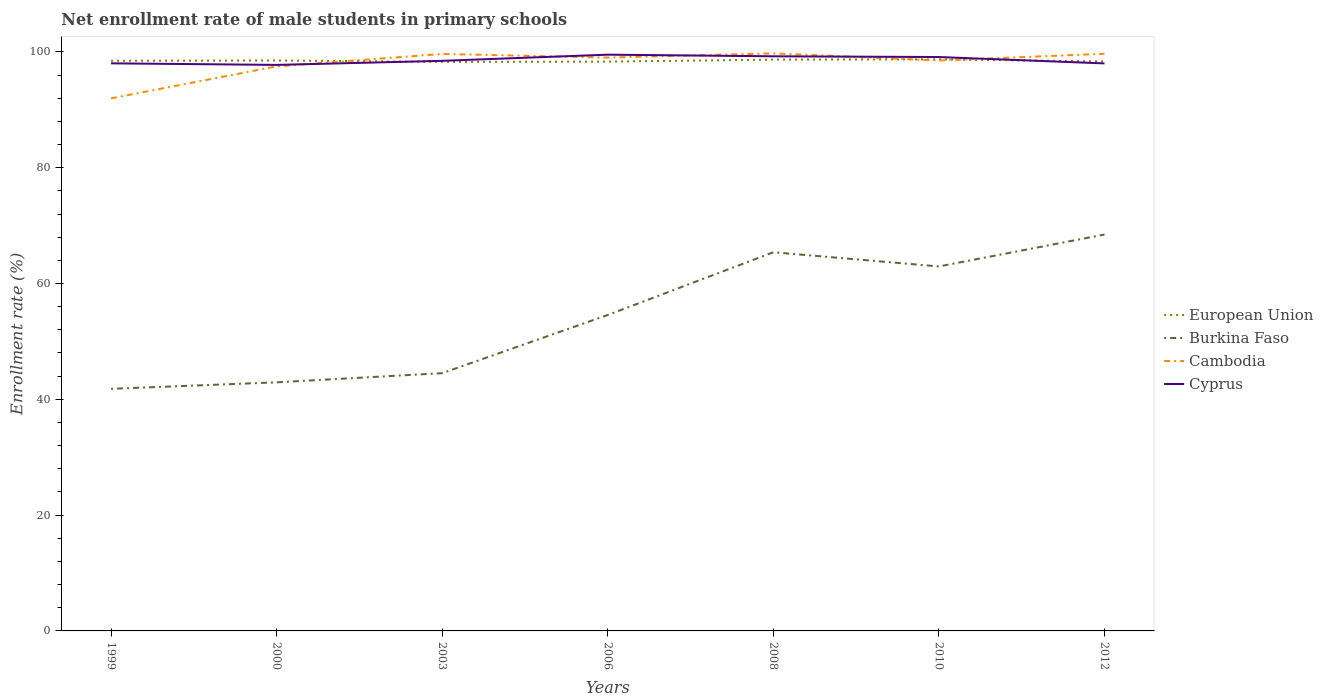Does the line corresponding to Cyprus intersect with the line corresponding to European Union?
Offer a terse response. Yes. Is the number of lines equal to the number of legend labels?
Provide a succinct answer. Yes. Across all years, what is the maximum net enrollment rate of male students in primary schools in Burkina Faso?
Provide a succinct answer. 41.81. What is the total net enrollment rate of male students in primary schools in Burkina Faso in the graph?
Your answer should be very brief. -20.01. What is the difference between the highest and the second highest net enrollment rate of male students in primary schools in Cyprus?
Make the answer very short. 1.77. How many lines are there?
Provide a short and direct response. 4. How many years are there in the graph?
Your response must be concise. 7. Where does the legend appear in the graph?
Your answer should be compact. Center right. How many legend labels are there?
Give a very brief answer. 4. What is the title of the graph?
Your response must be concise. Net enrollment rate of male students in primary schools. What is the label or title of the X-axis?
Provide a short and direct response. Years. What is the label or title of the Y-axis?
Give a very brief answer. Enrollment rate (%). What is the Enrollment rate (%) in European Union in 1999?
Give a very brief answer. 98.46. What is the Enrollment rate (%) of Burkina Faso in 1999?
Keep it short and to the point. 41.81. What is the Enrollment rate (%) in Cambodia in 1999?
Offer a very short reply. 91.98. What is the Enrollment rate (%) in Cyprus in 1999?
Offer a terse response. 98.03. What is the Enrollment rate (%) in European Union in 2000?
Ensure brevity in your answer.  98.53. What is the Enrollment rate (%) of Burkina Faso in 2000?
Keep it short and to the point. 42.94. What is the Enrollment rate (%) in Cambodia in 2000?
Give a very brief answer. 97.51. What is the Enrollment rate (%) of Cyprus in 2000?
Keep it short and to the point. 97.76. What is the Enrollment rate (%) of European Union in 2003?
Offer a very short reply. 98.28. What is the Enrollment rate (%) in Burkina Faso in 2003?
Your response must be concise. 44.52. What is the Enrollment rate (%) in Cambodia in 2003?
Your answer should be very brief. 99.65. What is the Enrollment rate (%) in Cyprus in 2003?
Keep it short and to the point. 98.46. What is the Enrollment rate (%) in European Union in 2006?
Your answer should be very brief. 98.32. What is the Enrollment rate (%) of Burkina Faso in 2006?
Make the answer very short. 54.57. What is the Enrollment rate (%) in Cambodia in 2006?
Provide a succinct answer. 99.02. What is the Enrollment rate (%) of Cyprus in 2006?
Offer a terse response. 99.52. What is the Enrollment rate (%) of European Union in 2008?
Ensure brevity in your answer.  98.67. What is the Enrollment rate (%) of Burkina Faso in 2008?
Ensure brevity in your answer.  65.4. What is the Enrollment rate (%) of Cambodia in 2008?
Provide a short and direct response. 99.75. What is the Enrollment rate (%) of Cyprus in 2008?
Ensure brevity in your answer.  99.24. What is the Enrollment rate (%) in European Union in 2010?
Make the answer very short. 98.72. What is the Enrollment rate (%) in Burkina Faso in 2010?
Provide a short and direct response. 62.95. What is the Enrollment rate (%) of Cambodia in 2010?
Your response must be concise. 98.52. What is the Enrollment rate (%) in Cyprus in 2010?
Ensure brevity in your answer.  99.12. What is the Enrollment rate (%) in European Union in 2012?
Make the answer very short. 98.35. What is the Enrollment rate (%) in Burkina Faso in 2012?
Ensure brevity in your answer.  68.46. What is the Enrollment rate (%) in Cambodia in 2012?
Your answer should be very brief. 99.68. What is the Enrollment rate (%) in Cyprus in 2012?
Your answer should be compact. 98.02. Across all years, what is the maximum Enrollment rate (%) of European Union?
Ensure brevity in your answer.  98.72. Across all years, what is the maximum Enrollment rate (%) in Burkina Faso?
Provide a short and direct response. 68.46. Across all years, what is the maximum Enrollment rate (%) in Cambodia?
Offer a very short reply. 99.75. Across all years, what is the maximum Enrollment rate (%) of Cyprus?
Offer a terse response. 99.52. Across all years, what is the minimum Enrollment rate (%) in European Union?
Provide a succinct answer. 98.28. Across all years, what is the minimum Enrollment rate (%) of Burkina Faso?
Keep it short and to the point. 41.81. Across all years, what is the minimum Enrollment rate (%) of Cambodia?
Your answer should be compact. 91.98. Across all years, what is the minimum Enrollment rate (%) of Cyprus?
Give a very brief answer. 97.76. What is the total Enrollment rate (%) of European Union in the graph?
Offer a very short reply. 689.32. What is the total Enrollment rate (%) in Burkina Faso in the graph?
Your response must be concise. 380.64. What is the total Enrollment rate (%) of Cambodia in the graph?
Your answer should be compact. 686.11. What is the total Enrollment rate (%) of Cyprus in the graph?
Your answer should be very brief. 690.14. What is the difference between the Enrollment rate (%) of European Union in 1999 and that in 2000?
Your answer should be very brief. -0.06. What is the difference between the Enrollment rate (%) of Burkina Faso in 1999 and that in 2000?
Give a very brief answer. -1.12. What is the difference between the Enrollment rate (%) of Cambodia in 1999 and that in 2000?
Offer a terse response. -5.53. What is the difference between the Enrollment rate (%) of Cyprus in 1999 and that in 2000?
Offer a very short reply. 0.27. What is the difference between the Enrollment rate (%) of European Union in 1999 and that in 2003?
Keep it short and to the point. 0.19. What is the difference between the Enrollment rate (%) in Burkina Faso in 1999 and that in 2003?
Ensure brevity in your answer.  -2.7. What is the difference between the Enrollment rate (%) of Cambodia in 1999 and that in 2003?
Provide a succinct answer. -7.67. What is the difference between the Enrollment rate (%) of Cyprus in 1999 and that in 2003?
Offer a terse response. -0.43. What is the difference between the Enrollment rate (%) of European Union in 1999 and that in 2006?
Offer a very short reply. 0.14. What is the difference between the Enrollment rate (%) of Burkina Faso in 1999 and that in 2006?
Offer a terse response. -12.75. What is the difference between the Enrollment rate (%) in Cambodia in 1999 and that in 2006?
Give a very brief answer. -7.04. What is the difference between the Enrollment rate (%) in Cyprus in 1999 and that in 2006?
Give a very brief answer. -1.49. What is the difference between the Enrollment rate (%) of European Union in 1999 and that in 2008?
Your answer should be compact. -0.21. What is the difference between the Enrollment rate (%) of Burkina Faso in 1999 and that in 2008?
Give a very brief answer. -23.59. What is the difference between the Enrollment rate (%) in Cambodia in 1999 and that in 2008?
Provide a succinct answer. -7.77. What is the difference between the Enrollment rate (%) in Cyprus in 1999 and that in 2008?
Keep it short and to the point. -1.21. What is the difference between the Enrollment rate (%) in European Union in 1999 and that in 2010?
Provide a short and direct response. -0.26. What is the difference between the Enrollment rate (%) of Burkina Faso in 1999 and that in 2010?
Offer a very short reply. -21.14. What is the difference between the Enrollment rate (%) of Cambodia in 1999 and that in 2010?
Provide a succinct answer. -6.54. What is the difference between the Enrollment rate (%) in Cyprus in 1999 and that in 2010?
Make the answer very short. -1.09. What is the difference between the Enrollment rate (%) in European Union in 1999 and that in 2012?
Offer a terse response. 0.11. What is the difference between the Enrollment rate (%) of Burkina Faso in 1999 and that in 2012?
Your answer should be very brief. -26.64. What is the difference between the Enrollment rate (%) of Cambodia in 1999 and that in 2012?
Your answer should be compact. -7.7. What is the difference between the Enrollment rate (%) of Cyprus in 1999 and that in 2012?
Offer a terse response. 0.01. What is the difference between the Enrollment rate (%) of European Union in 2000 and that in 2003?
Give a very brief answer. 0.25. What is the difference between the Enrollment rate (%) of Burkina Faso in 2000 and that in 2003?
Ensure brevity in your answer.  -1.58. What is the difference between the Enrollment rate (%) of Cambodia in 2000 and that in 2003?
Offer a terse response. -2.14. What is the difference between the Enrollment rate (%) of Cyprus in 2000 and that in 2003?
Make the answer very short. -0.71. What is the difference between the Enrollment rate (%) in European Union in 2000 and that in 2006?
Provide a succinct answer. 0.2. What is the difference between the Enrollment rate (%) in Burkina Faso in 2000 and that in 2006?
Give a very brief answer. -11.63. What is the difference between the Enrollment rate (%) of Cambodia in 2000 and that in 2006?
Provide a short and direct response. -1.51. What is the difference between the Enrollment rate (%) of Cyprus in 2000 and that in 2006?
Offer a terse response. -1.77. What is the difference between the Enrollment rate (%) of European Union in 2000 and that in 2008?
Ensure brevity in your answer.  -0.14. What is the difference between the Enrollment rate (%) of Burkina Faso in 2000 and that in 2008?
Offer a very short reply. -22.46. What is the difference between the Enrollment rate (%) of Cambodia in 2000 and that in 2008?
Your answer should be compact. -2.24. What is the difference between the Enrollment rate (%) in Cyprus in 2000 and that in 2008?
Provide a short and direct response. -1.49. What is the difference between the Enrollment rate (%) of European Union in 2000 and that in 2010?
Your answer should be compact. -0.19. What is the difference between the Enrollment rate (%) of Burkina Faso in 2000 and that in 2010?
Provide a short and direct response. -20.01. What is the difference between the Enrollment rate (%) of Cambodia in 2000 and that in 2010?
Make the answer very short. -1.01. What is the difference between the Enrollment rate (%) in Cyprus in 2000 and that in 2010?
Give a very brief answer. -1.36. What is the difference between the Enrollment rate (%) of European Union in 2000 and that in 2012?
Your answer should be compact. 0.17. What is the difference between the Enrollment rate (%) of Burkina Faso in 2000 and that in 2012?
Make the answer very short. -25.52. What is the difference between the Enrollment rate (%) of Cambodia in 2000 and that in 2012?
Offer a very short reply. -2.17. What is the difference between the Enrollment rate (%) in Cyprus in 2000 and that in 2012?
Ensure brevity in your answer.  -0.26. What is the difference between the Enrollment rate (%) in European Union in 2003 and that in 2006?
Your answer should be very brief. -0.05. What is the difference between the Enrollment rate (%) in Burkina Faso in 2003 and that in 2006?
Provide a short and direct response. -10.05. What is the difference between the Enrollment rate (%) of Cambodia in 2003 and that in 2006?
Give a very brief answer. 0.63. What is the difference between the Enrollment rate (%) of Cyprus in 2003 and that in 2006?
Provide a short and direct response. -1.06. What is the difference between the Enrollment rate (%) of European Union in 2003 and that in 2008?
Provide a succinct answer. -0.39. What is the difference between the Enrollment rate (%) in Burkina Faso in 2003 and that in 2008?
Offer a very short reply. -20.88. What is the difference between the Enrollment rate (%) in Cambodia in 2003 and that in 2008?
Provide a succinct answer. -0.1. What is the difference between the Enrollment rate (%) in Cyprus in 2003 and that in 2008?
Your response must be concise. -0.78. What is the difference between the Enrollment rate (%) of European Union in 2003 and that in 2010?
Keep it short and to the point. -0.44. What is the difference between the Enrollment rate (%) in Burkina Faso in 2003 and that in 2010?
Your response must be concise. -18.43. What is the difference between the Enrollment rate (%) in Cambodia in 2003 and that in 2010?
Ensure brevity in your answer.  1.13. What is the difference between the Enrollment rate (%) in Cyprus in 2003 and that in 2010?
Offer a very short reply. -0.65. What is the difference between the Enrollment rate (%) in European Union in 2003 and that in 2012?
Your answer should be compact. -0.08. What is the difference between the Enrollment rate (%) in Burkina Faso in 2003 and that in 2012?
Make the answer very short. -23.94. What is the difference between the Enrollment rate (%) of Cambodia in 2003 and that in 2012?
Offer a terse response. -0.03. What is the difference between the Enrollment rate (%) of Cyprus in 2003 and that in 2012?
Offer a terse response. 0.45. What is the difference between the Enrollment rate (%) of European Union in 2006 and that in 2008?
Offer a terse response. -0.35. What is the difference between the Enrollment rate (%) in Burkina Faso in 2006 and that in 2008?
Offer a terse response. -10.83. What is the difference between the Enrollment rate (%) in Cambodia in 2006 and that in 2008?
Offer a terse response. -0.73. What is the difference between the Enrollment rate (%) in Cyprus in 2006 and that in 2008?
Your answer should be very brief. 0.28. What is the difference between the Enrollment rate (%) of European Union in 2006 and that in 2010?
Your answer should be very brief. -0.39. What is the difference between the Enrollment rate (%) in Burkina Faso in 2006 and that in 2010?
Offer a very short reply. -8.38. What is the difference between the Enrollment rate (%) of Cambodia in 2006 and that in 2010?
Keep it short and to the point. 0.51. What is the difference between the Enrollment rate (%) of Cyprus in 2006 and that in 2010?
Your response must be concise. 0.41. What is the difference between the Enrollment rate (%) in European Union in 2006 and that in 2012?
Offer a terse response. -0.03. What is the difference between the Enrollment rate (%) in Burkina Faso in 2006 and that in 2012?
Give a very brief answer. -13.89. What is the difference between the Enrollment rate (%) in Cambodia in 2006 and that in 2012?
Make the answer very short. -0.66. What is the difference between the Enrollment rate (%) of Cyprus in 2006 and that in 2012?
Offer a terse response. 1.51. What is the difference between the Enrollment rate (%) of European Union in 2008 and that in 2010?
Your answer should be very brief. -0.05. What is the difference between the Enrollment rate (%) of Burkina Faso in 2008 and that in 2010?
Your answer should be compact. 2.45. What is the difference between the Enrollment rate (%) of Cambodia in 2008 and that in 2010?
Provide a short and direct response. 1.24. What is the difference between the Enrollment rate (%) of Cyprus in 2008 and that in 2010?
Your answer should be very brief. 0.13. What is the difference between the Enrollment rate (%) of European Union in 2008 and that in 2012?
Ensure brevity in your answer.  0.32. What is the difference between the Enrollment rate (%) in Burkina Faso in 2008 and that in 2012?
Provide a short and direct response. -3.06. What is the difference between the Enrollment rate (%) of Cambodia in 2008 and that in 2012?
Make the answer very short. 0.07. What is the difference between the Enrollment rate (%) in Cyprus in 2008 and that in 2012?
Your response must be concise. 1.23. What is the difference between the Enrollment rate (%) of European Union in 2010 and that in 2012?
Give a very brief answer. 0.37. What is the difference between the Enrollment rate (%) in Burkina Faso in 2010 and that in 2012?
Keep it short and to the point. -5.51. What is the difference between the Enrollment rate (%) in Cambodia in 2010 and that in 2012?
Your answer should be very brief. -1.16. What is the difference between the Enrollment rate (%) of Cyprus in 2010 and that in 2012?
Make the answer very short. 1.1. What is the difference between the Enrollment rate (%) of European Union in 1999 and the Enrollment rate (%) of Burkina Faso in 2000?
Your answer should be compact. 55.53. What is the difference between the Enrollment rate (%) of European Union in 1999 and the Enrollment rate (%) of Cambodia in 2000?
Your answer should be very brief. 0.95. What is the difference between the Enrollment rate (%) of European Union in 1999 and the Enrollment rate (%) of Cyprus in 2000?
Make the answer very short. 0.71. What is the difference between the Enrollment rate (%) in Burkina Faso in 1999 and the Enrollment rate (%) in Cambodia in 2000?
Give a very brief answer. -55.7. What is the difference between the Enrollment rate (%) of Burkina Faso in 1999 and the Enrollment rate (%) of Cyprus in 2000?
Offer a terse response. -55.94. What is the difference between the Enrollment rate (%) in Cambodia in 1999 and the Enrollment rate (%) in Cyprus in 2000?
Provide a succinct answer. -5.77. What is the difference between the Enrollment rate (%) in European Union in 1999 and the Enrollment rate (%) in Burkina Faso in 2003?
Provide a short and direct response. 53.94. What is the difference between the Enrollment rate (%) of European Union in 1999 and the Enrollment rate (%) of Cambodia in 2003?
Your answer should be compact. -1.19. What is the difference between the Enrollment rate (%) of European Union in 1999 and the Enrollment rate (%) of Cyprus in 2003?
Ensure brevity in your answer.  -0. What is the difference between the Enrollment rate (%) in Burkina Faso in 1999 and the Enrollment rate (%) in Cambodia in 2003?
Ensure brevity in your answer.  -57.84. What is the difference between the Enrollment rate (%) of Burkina Faso in 1999 and the Enrollment rate (%) of Cyprus in 2003?
Ensure brevity in your answer.  -56.65. What is the difference between the Enrollment rate (%) of Cambodia in 1999 and the Enrollment rate (%) of Cyprus in 2003?
Offer a terse response. -6.48. What is the difference between the Enrollment rate (%) in European Union in 1999 and the Enrollment rate (%) in Burkina Faso in 2006?
Your answer should be very brief. 43.89. What is the difference between the Enrollment rate (%) of European Union in 1999 and the Enrollment rate (%) of Cambodia in 2006?
Give a very brief answer. -0.56. What is the difference between the Enrollment rate (%) in European Union in 1999 and the Enrollment rate (%) in Cyprus in 2006?
Your answer should be compact. -1.06. What is the difference between the Enrollment rate (%) of Burkina Faso in 1999 and the Enrollment rate (%) of Cambodia in 2006?
Ensure brevity in your answer.  -57.21. What is the difference between the Enrollment rate (%) in Burkina Faso in 1999 and the Enrollment rate (%) in Cyprus in 2006?
Provide a succinct answer. -57.71. What is the difference between the Enrollment rate (%) of Cambodia in 1999 and the Enrollment rate (%) of Cyprus in 2006?
Ensure brevity in your answer.  -7.54. What is the difference between the Enrollment rate (%) in European Union in 1999 and the Enrollment rate (%) in Burkina Faso in 2008?
Your answer should be compact. 33.06. What is the difference between the Enrollment rate (%) in European Union in 1999 and the Enrollment rate (%) in Cambodia in 2008?
Provide a succinct answer. -1.29. What is the difference between the Enrollment rate (%) of European Union in 1999 and the Enrollment rate (%) of Cyprus in 2008?
Offer a terse response. -0.78. What is the difference between the Enrollment rate (%) in Burkina Faso in 1999 and the Enrollment rate (%) in Cambodia in 2008?
Ensure brevity in your answer.  -57.94. What is the difference between the Enrollment rate (%) of Burkina Faso in 1999 and the Enrollment rate (%) of Cyprus in 2008?
Provide a short and direct response. -57.43. What is the difference between the Enrollment rate (%) of Cambodia in 1999 and the Enrollment rate (%) of Cyprus in 2008?
Provide a succinct answer. -7.26. What is the difference between the Enrollment rate (%) in European Union in 1999 and the Enrollment rate (%) in Burkina Faso in 2010?
Offer a very short reply. 35.51. What is the difference between the Enrollment rate (%) of European Union in 1999 and the Enrollment rate (%) of Cambodia in 2010?
Make the answer very short. -0.06. What is the difference between the Enrollment rate (%) of European Union in 1999 and the Enrollment rate (%) of Cyprus in 2010?
Make the answer very short. -0.65. What is the difference between the Enrollment rate (%) of Burkina Faso in 1999 and the Enrollment rate (%) of Cambodia in 2010?
Provide a short and direct response. -56.7. What is the difference between the Enrollment rate (%) of Burkina Faso in 1999 and the Enrollment rate (%) of Cyprus in 2010?
Give a very brief answer. -57.3. What is the difference between the Enrollment rate (%) in Cambodia in 1999 and the Enrollment rate (%) in Cyprus in 2010?
Offer a terse response. -7.13. What is the difference between the Enrollment rate (%) of European Union in 1999 and the Enrollment rate (%) of Burkina Faso in 2012?
Your answer should be compact. 30.01. What is the difference between the Enrollment rate (%) of European Union in 1999 and the Enrollment rate (%) of Cambodia in 2012?
Provide a short and direct response. -1.22. What is the difference between the Enrollment rate (%) in European Union in 1999 and the Enrollment rate (%) in Cyprus in 2012?
Provide a short and direct response. 0.44. What is the difference between the Enrollment rate (%) in Burkina Faso in 1999 and the Enrollment rate (%) in Cambodia in 2012?
Give a very brief answer. -57.87. What is the difference between the Enrollment rate (%) in Burkina Faso in 1999 and the Enrollment rate (%) in Cyprus in 2012?
Provide a succinct answer. -56.2. What is the difference between the Enrollment rate (%) of Cambodia in 1999 and the Enrollment rate (%) of Cyprus in 2012?
Make the answer very short. -6.04. What is the difference between the Enrollment rate (%) in European Union in 2000 and the Enrollment rate (%) in Burkina Faso in 2003?
Your answer should be very brief. 54.01. What is the difference between the Enrollment rate (%) in European Union in 2000 and the Enrollment rate (%) in Cambodia in 2003?
Your answer should be very brief. -1.12. What is the difference between the Enrollment rate (%) in European Union in 2000 and the Enrollment rate (%) in Cyprus in 2003?
Provide a succinct answer. 0.06. What is the difference between the Enrollment rate (%) of Burkina Faso in 2000 and the Enrollment rate (%) of Cambodia in 2003?
Your answer should be compact. -56.71. What is the difference between the Enrollment rate (%) in Burkina Faso in 2000 and the Enrollment rate (%) in Cyprus in 2003?
Provide a short and direct response. -55.53. What is the difference between the Enrollment rate (%) in Cambodia in 2000 and the Enrollment rate (%) in Cyprus in 2003?
Your answer should be very brief. -0.95. What is the difference between the Enrollment rate (%) of European Union in 2000 and the Enrollment rate (%) of Burkina Faso in 2006?
Provide a short and direct response. 43.96. What is the difference between the Enrollment rate (%) in European Union in 2000 and the Enrollment rate (%) in Cambodia in 2006?
Your response must be concise. -0.5. What is the difference between the Enrollment rate (%) of European Union in 2000 and the Enrollment rate (%) of Cyprus in 2006?
Offer a very short reply. -1. What is the difference between the Enrollment rate (%) in Burkina Faso in 2000 and the Enrollment rate (%) in Cambodia in 2006?
Your answer should be very brief. -56.09. What is the difference between the Enrollment rate (%) in Burkina Faso in 2000 and the Enrollment rate (%) in Cyprus in 2006?
Make the answer very short. -56.59. What is the difference between the Enrollment rate (%) of Cambodia in 2000 and the Enrollment rate (%) of Cyprus in 2006?
Your answer should be compact. -2.01. What is the difference between the Enrollment rate (%) of European Union in 2000 and the Enrollment rate (%) of Burkina Faso in 2008?
Provide a succinct answer. 33.12. What is the difference between the Enrollment rate (%) of European Union in 2000 and the Enrollment rate (%) of Cambodia in 2008?
Keep it short and to the point. -1.23. What is the difference between the Enrollment rate (%) in European Union in 2000 and the Enrollment rate (%) in Cyprus in 2008?
Provide a short and direct response. -0.72. What is the difference between the Enrollment rate (%) of Burkina Faso in 2000 and the Enrollment rate (%) of Cambodia in 2008?
Keep it short and to the point. -56.82. What is the difference between the Enrollment rate (%) of Burkina Faso in 2000 and the Enrollment rate (%) of Cyprus in 2008?
Make the answer very short. -56.31. What is the difference between the Enrollment rate (%) of Cambodia in 2000 and the Enrollment rate (%) of Cyprus in 2008?
Offer a very short reply. -1.73. What is the difference between the Enrollment rate (%) in European Union in 2000 and the Enrollment rate (%) in Burkina Faso in 2010?
Keep it short and to the point. 35.58. What is the difference between the Enrollment rate (%) in European Union in 2000 and the Enrollment rate (%) in Cambodia in 2010?
Offer a terse response. 0.01. What is the difference between the Enrollment rate (%) of European Union in 2000 and the Enrollment rate (%) of Cyprus in 2010?
Keep it short and to the point. -0.59. What is the difference between the Enrollment rate (%) in Burkina Faso in 2000 and the Enrollment rate (%) in Cambodia in 2010?
Keep it short and to the point. -55.58. What is the difference between the Enrollment rate (%) of Burkina Faso in 2000 and the Enrollment rate (%) of Cyprus in 2010?
Make the answer very short. -56.18. What is the difference between the Enrollment rate (%) in Cambodia in 2000 and the Enrollment rate (%) in Cyprus in 2010?
Your answer should be very brief. -1.61. What is the difference between the Enrollment rate (%) in European Union in 2000 and the Enrollment rate (%) in Burkina Faso in 2012?
Provide a succinct answer. 30.07. What is the difference between the Enrollment rate (%) of European Union in 2000 and the Enrollment rate (%) of Cambodia in 2012?
Provide a succinct answer. -1.16. What is the difference between the Enrollment rate (%) in European Union in 2000 and the Enrollment rate (%) in Cyprus in 2012?
Your answer should be very brief. 0.51. What is the difference between the Enrollment rate (%) of Burkina Faso in 2000 and the Enrollment rate (%) of Cambodia in 2012?
Give a very brief answer. -56.74. What is the difference between the Enrollment rate (%) of Burkina Faso in 2000 and the Enrollment rate (%) of Cyprus in 2012?
Provide a short and direct response. -55.08. What is the difference between the Enrollment rate (%) of Cambodia in 2000 and the Enrollment rate (%) of Cyprus in 2012?
Make the answer very short. -0.51. What is the difference between the Enrollment rate (%) of European Union in 2003 and the Enrollment rate (%) of Burkina Faso in 2006?
Your response must be concise. 43.71. What is the difference between the Enrollment rate (%) in European Union in 2003 and the Enrollment rate (%) in Cambodia in 2006?
Keep it short and to the point. -0.75. What is the difference between the Enrollment rate (%) of European Union in 2003 and the Enrollment rate (%) of Cyprus in 2006?
Provide a succinct answer. -1.25. What is the difference between the Enrollment rate (%) of Burkina Faso in 2003 and the Enrollment rate (%) of Cambodia in 2006?
Your answer should be compact. -54.51. What is the difference between the Enrollment rate (%) of Burkina Faso in 2003 and the Enrollment rate (%) of Cyprus in 2006?
Your answer should be compact. -55.01. What is the difference between the Enrollment rate (%) of Cambodia in 2003 and the Enrollment rate (%) of Cyprus in 2006?
Keep it short and to the point. 0.13. What is the difference between the Enrollment rate (%) of European Union in 2003 and the Enrollment rate (%) of Burkina Faso in 2008?
Provide a short and direct response. 32.88. What is the difference between the Enrollment rate (%) of European Union in 2003 and the Enrollment rate (%) of Cambodia in 2008?
Offer a very short reply. -1.48. What is the difference between the Enrollment rate (%) in European Union in 2003 and the Enrollment rate (%) in Cyprus in 2008?
Offer a very short reply. -0.97. What is the difference between the Enrollment rate (%) of Burkina Faso in 2003 and the Enrollment rate (%) of Cambodia in 2008?
Your answer should be very brief. -55.24. What is the difference between the Enrollment rate (%) of Burkina Faso in 2003 and the Enrollment rate (%) of Cyprus in 2008?
Make the answer very short. -54.73. What is the difference between the Enrollment rate (%) of Cambodia in 2003 and the Enrollment rate (%) of Cyprus in 2008?
Give a very brief answer. 0.41. What is the difference between the Enrollment rate (%) in European Union in 2003 and the Enrollment rate (%) in Burkina Faso in 2010?
Keep it short and to the point. 35.33. What is the difference between the Enrollment rate (%) in European Union in 2003 and the Enrollment rate (%) in Cambodia in 2010?
Keep it short and to the point. -0.24. What is the difference between the Enrollment rate (%) in European Union in 2003 and the Enrollment rate (%) in Cyprus in 2010?
Give a very brief answer. -0.84. What is the difference between the Enrollment rate (%) in Burkina Faso in 2003 and the Enrollment rate (%) in Cambodia in 2010?
Ensure brevity in your answer.  -54. What is the difference between the Enrollment rate (%) in Burkina Faso in 2003 and the Enrollment rate (%) in Cyprus in 2010?
Provide a short and direct response. -54.6. What is the difference between the Enrollment rate (%) in Cambodia in 2003 and the Enrollment rate (%) in Cyprus in 2010?
Make the answer very short. 0.53. What is the difference between the Enrollment rate (%) of European Union in 2003 and the Enrollment rate (%) of Burkina Faso in 2012?
Ensure brevity in your answer.  29.82. What is the difference between the Enrollment rate (%) of European Union in 2003 and the Enrollment rate (%) of Cambodia in 2012?
Make the answer very short. -1.4. What is the difference between the Enrollment rate (%) of European Union in 2003 and the Enrollment rate (%) of Cyprus in 2012?
Provide a short and direct response. 0.26. What is the difference between the Enrollment rate (%) in Burkina Faso in 2003 and the Enrollment rate (%) in Cambodia in 2012?
Provide a succinct answer. -55.16. What is the difference between the Enrollment rate (%) of Burkina Faso in 2003 and the Enrollment rate (%) of Cyprus in 2012?
Your answer should be very brief. -53.5. What is the difference between the Enrollment rate (%) of Cambodia in 2003 and the Enrollment rate (%) of Cyprus in 2012?
Your answer should be compact. 1.63. What is the difference between the Enrollment rate (%) in European Union in 2006 and the Enrollment rate (%) in Burkina Faso in 2008?
Offer a terse response. 32.92. What is the difference between the Enrollment rate (%) in European Union in 2006 and the Enrollment rate (%) in Cambodia in 2008?
Your answer should be compact. -1.43. What is the difference between the Enrollment rate (%) in European Union in 2006 and the Enrollment rate (%) in Cyprus in 2008?
Your answer should be compact. -0.92. What is the difference between the Enrollment rate (%) in Burkina Faso in 2006 and the Enrollment rate (%) in Cambodia in 2008?
Give a very brief answer. -45.18. What is the difference between the Enrollment rate (%) of Burkina Faso in 2006 and the Enrollment rate (%) of Cyprus in 2008?
Give a very brief answer. -44.67. What is the difference between the Enrollment rate (%) in Cambodia in 2006 and the Enrollment rate (%) in Cyprus in 2008?
Keep it short and to the point. -0.22. What is the difference between the Enrollment rate (%) in European Union in 2006 and the Enrollment rate (%) in Burkina Faso in 2010?
Make the answer very short. 35.37. What is the difference between the Enrollment rate (%) in European Union in 2006 and the Enrollment rate (%) in Cambodia in 2010?
Your response must be concise. -0.19. What is the difference between the Enrollment rate (%) in European Union in 2006 and the Enrollment rate (%) in Cyprus in 2010?
Keep it short and to the point. -0.79. What is the difference between the Enrollment rate (%) of Burkina Faso in 2006 and the Enrollment rate (%) of Cambodia in 2010?
Your answer should be compact. -43.95. What is the difference between the Enrollment rate (%) in Burkina Faso in 2006 and the Enrollment rate (%) in Cyprus in 2010?
Offer a terse response. -44.55. What is the difference between the Enrollment rate (%) of Cambodia in 2006 and the Enrollment rate (%) of Cyprus in 2010?
Keep it short and to the point. -0.09. What is the difference between the Enrollment rate (%) of European Union in 2006 and the Enrollment rate (%) of Burkina Faso in 2012?
Make the answer very short. 29.87. What is the difference between the Enrollment rate (%) of European Union in 2006 and the Enrollment rate (%) of Cambodia in 2012?
Offer a terse response. -1.36. What is the difference between the Enrollment rate (%) in European Union in 2006 and the Enrollment rate (%) in Cyprus in 2012?
Your answer should be compact. 0.31. What is the difference between the Enrollment rate (%) in Burkina Faso in 2006 and the Enrollment rate (%) in Cambodia in 2012?
Provide a succinct answer. -45.11. What is the difference between the Enrollment rate (%) in Burkina Faso in 2006 and the Enrollment rate (%) in Cyprus in 2012?
Ensure brevity in your answer.  -43.45. What is the difference between the Enrollment rate (%) in Cambodia in 2006 and the Enrollment rate (%) in Cyprus in 2012?
Keep it short and to the point. 1.01. What is the difference between the Enrollment rate (%) of European Union in 2008 and the Enrollment rate (%) of Burkina Faso in 2010?
Keep it short and to the point. 35.72. What is the difference between the Enrollment rate (%) of European Union in 2008 and the Enrollment rate (%) of Cambodia in 2010?
Your response must be concise. 0.15. What is the difference between the Enrollment rate (%) of European Union in 2008 and the Enrollment rate (%) of Cyprus in 2010?
Your answer should be compact. -0.45. What is the difference between the Enrollment rate (%) in Burkina Faso in 2008 and the Enrollment rate (%) in Cambodia in 2010?
Give a very brief answer. -33.12. What is the difference between the Enrollment rate (%) of Burkina Faso in 2008 and the Enrollment rate (%) of Cyprus in 2010?
Give a very brief answer. -33.72. What is the difference between the Enrollment rate (%) in Cambodia in 2008 and the Enrollment rate (%) in Cyprus in 2010?
Your response must be concise. 0.64. What is the difference between the Enrollment rate (%) of European Union in 2008 and the Enrollment rate (%) of Burkina Faso in 2012?
Provide a short and direct response. 30.21. What is the difference between the Enrollment rate (%) in European Union in 2008 and the Enrollment rate (%) in Cambodia in 2012?
Offer a very short reply. -1.01. What is the difference between the Enrollment rate (%) in European Union in 2008 and the Enrollment rate (%) in Cyprus in 2012?
Keep it short and to the point. 0.65. What is the difference between the Enrollment rate (%) in Burkina Faso in 2008 and the Enrollment rate (%) in Cambodia in 2012?
Offer a terse response. -34.28. What is the difference between the Enrollment rate (%) in Burkina Faso in 2008 and the Enrollment rate (%) in Cyprus in 2012?
Provide a succinct answer. -32.62. What is the difference between the Enrollment rate (%) in Cambodia in 2008 and the Enrollment rate (%) in Cyprus in 2012?
Give a very brief answer. 1.74. What is the difference between the Enrollment rate (%) of European Union in 2010 and the Enrollment rate (%) of Burkina Faso in 2012?
Offer a terse response. 30.26. What is the difference between the Enrollment rate (%) in European Union in 2010 and the Enrollment rate (%) in Cambodia in 2012?
Give a very brief answer. -0.96. What is the difference between the Enrollment rate (%) in European Union in 2010 and the Enrollment rate (%) in Cyprus in 2012?
Offer a terse response. 0.7. What is the difference between the Enrollment rate (%) of Burkina Faso in 2010 and the Enrollment rate (%) of Cambodia in 2012?
Your response must be concise. -36.73. What is the difference between the Enrollment rate (%) in Burkina Faso in 2010 and the Enrollment rate (%) in Cyprus in 2012?
Give a very brief answer. -35.07. What is the difference between the Enrollment rate (%) in Cambodia in 2010 and the Enrollment rate (%) in Cyprus in 2012?
Keep it short and to the point. 0.5. What is the average Enrollment rate (%) in European Union per year?
Your answer should be compact. 98.47. What is the average Enrollment rate (%) of Burkina Faso per year?
Make the answer very short. 54.38. What is the average Enrollment rate (%) of Cambodia per year?
Provide a succinct answer. 98.02. What is the average Enrollment rate (%) of Cyprus per year?
Provide a succinct answer. 98.59. In the year 1999, what is the difference between the Enrollment rate (%) of European Union and Enrollment rate (%) of Burkina Faso?
Offer a very short reply. 56.65. In the year 1999, what is the difference between the Enrollment rate (%) of European Union and Enrollment rate (%) of Cambodia?
Offer a very short reply. 6.48. In the year 1999, what is the difference between the Enrollment rate (%) in European Union and Enrollment rate (%) in Cyprus?
Your response must be concise. 0.43. In the year 1999, what is the difference between the Enrollment rate (%) of Burkina Faso and Enrollment rate (%) of Cambodia?
Keep it short and to the point. -50.17. In the year 1999, what is the difference between the Enrollment rate (%) of Burkina Faso and Enrollment rate (%) of Cyprus?
Make the answer very short. -56.22. In the year 1999, what is the difference between the Enrollment rate (%) of Cambodia and Enrollment rate (%) of Cyprus?
Offer a very short reply. -6.05. In the year 2000, what is the difference between the Enrollment rate (%) of European Union and Enrollment rate (%) of Burkina Faso?
Ensure brevity in your answer.  55.59. In the year 2000, what is the difference between the Enrollment rate (%) in European Union and Enrollment rate (%) in Cambodia?
Give a very brief answer. 1.02. In the year 2000, what is the difference between the Enrollment rate (%) of European Union and Enrollment rate (%) of Cyprus?
Give a very brief answer. 0.77. In the year 2000, what is the difference between the Enrollment rate (%) in Burkina Faso and Enrollment rate (%) in Cambodia?
Provide a short and direct response. -54.57. In the year 2000, what is the difference between the Enrollment rate (%) in Burkina Faso and Enrollment rate (%) in Cyprus?
Provide a succinct answer. -54.82. In the year 2000, what is the difference between the Enrollment rate (%) of Cambodia and Enrollment rate (%) of Cyprus?
Offer a terse response. -0.25. In the year 2003, what is the difference between the Enrollment rate (%) in European Union and Enrollment rate (%) in Burkina Faso?
Provide a succinct answer. 53.76. In the year 2003, what is the difference between the Enrollment rate (%) of European Union and Enrollment rate (%) of Cambodia?
Your answer should be compact. -1.37. In the year 2003, what is the difference between the Enrollment rate (%) in European Union and Enrollment rate (%) in Cyprus?
Make the answer very short. -0.19. In the year 2003, what is the difference between the Enrollment rate (%) of Burkina Faso and Enrollment rate (%) of Cambodia?
Ensure brevity in your answer.  -55.13. In the year 2003, what is the difference between the Enrollment rate (%) in Burkina Faso and Enrollment rate (%) in Cyprus?
Give a very brief answer. -53.95. In the year 2003, what is the difference between the Enrollment rate (%) of Cambodia and Enrollment rate (%) of Cyprus?
Your answer should be compact. 1.19. In the year 2006, what is the difference between the Enrollment rate (%) of European Union and Enrollment rate (%) of Burkina Faso?
Give a very brief answer. 43.76. In the year 2006, what is the difference between the Enrollment rate (%) of European Union and Enrollment rate (%) of Cambodia?
Your answer should be compact. -0.7. In the year 2006, what is the difference between the Enrollment rate (%) of European Union and Enrollment rate (%) of Cyprus?
Keep it short and to the point. -1.2. In the year 2006, what is the difference between the Enrollment rate (%) in Burkina Faso and Enrollment rate (%) in Cambodia?
Offer a very short reply. -44.45. In the year 2006, what is the difference between the Enrollment rate (%) of Burkina Faso and Enrollment rate (%) of Cyprus?
Give a very brief answer. -44.96. In the year 2006, what is the difference between the Enrollment rate (%) of Cambodia and Enrollment rate (%) of Cyprus?
Ensure brevity in your answer.  -0.5. In the year 2008, what is the difference between the Enrollment rate (%) of European Union and Enrollment rate (%) of Burkina Faso?
Provide a succinct answer. 33.27. In the year 2008, what is the difference between the Enrollment rate (%) in European Union and Enrollment rate (%) in Cambodia?
Provide a succinct answer. -1.08. In the year 2008, what is the difference between the Enrollment rate (%) in European Union and Enrollment rate (%) in Cyprus?
Your answer should be very brief. -0.57. In the year 2008, what is the difference between the Enrollment rate (%) in Burkina Faso and Enrollment rate (%) in Cambodia?
Your answer should be very brief. -34.35. In the year 2008, what is the difference between the Enrollment rate (%) of Burkina Faso and Enrollment rate (%) of Cyprus?
Your response must be concise. -33.84. In the year 2008, what is the difference between the Enrollment rate (%) of Cambodia and Enrollment rate (%) of Cyprus?
Make the answer very short. 0.51. In the year 2010, what is the difference between the Enrollment rate (%) of European Union and Enrollment rate (%) of Burkina Faso?
Offer a very short reply. 35.77. In the year 2010, what is the difference between the Enrollment rate (%) of European Union and Enrollment rate (%) of Cambodia?
Make the answer very short. 0.2. In the year 2010, what is the difference between the Enrollment rate (%) in European Union and Enrollment rate (%) in Cyprus?
Offer a terse response. -0.4. In the year 2010, what is the difference between the Enrollment rate (%) of Burkina Faso and Enrollment rate (%) of Cambodia?
Your response must be concise. -35.57. In the year 2010, what is the difference between the Enrollment rate (%) of Burkina Faso and Enrollment rate (%) of Cyprus?
Make the answer very short. -36.17. In the year 2010, what is the difference between the Enrollment rate (%) in Cambodia and Enrollment rate (%) in Cyprus?
Your response must be concise. -0.6. In the year 2012, what is the difference between the Enrollment rate (%) of European Union and Enrollment rate (%) of Burkina Faso?
Provide a succinct answer. 29.9. In the year 2012, what is the difference between the Enrollment rate (%) in European Union and Enrollment rate (%) in Cambodia?
Keep it short and to the point. -1.33. In the year 2012, what is the difference between the Enrollment rate (%) in European Union and Enrollment rate (%) in Cyprus?
Offer a terse response. 0.34. In the year 2012, what is the difference between the Enrollment rate (%) of Burkina Faso and Enrollment rate (%) of Cambodia?
Make the answer very short. -31.22. In the year 2012, what is the difference between the Enrollment rate (%) of Burkina Faso and Enrollment rate (%) of Cyprus?
Provide a short and direct response. -29.56. In the year 2012, what is the difference between the Enrollment rate (%) of Cambodia and Enrollment rate (%) of Cyprus?
Keep it short and to the point. 1.66. What is the ratio of the Enrollment rate (%) in Burkina Faso in 1999 to that in 2000?
Offer a terse response. 0.97. What is the ratio of the Enrollment rate (%) in Cambodia in 1999 to that in 2000?
Ensure brevity in your answer.  0.94. What is the ratio of the Enrollment rate (%) in Cyprus in 1999 to that in 2000?
Offer a terse response. 1. What is the ratio of the Enrollment rate (%) in European Union in 1999 to that in 2003?
Offer a very short reply. 1. What is the ratio of the Enrollment rate (%) of Burkina Faso in 1999 to that in 2003?
Provide a short and direct response. 0.94. What is the ratio of the Enrollment rate (%) in Cambodia in 1999 to that in 2003?
Give a very brief answer. 0.92. What is the ratio of the Enrollment rate (%) of Cyprus in 1999 to that in 2003?
Provide a short and direct response. 1. What is the ratio of the Enrollment rate (%) of Burkina Faso in 1999 to that in 2006?
Your answer should be compact. 0.77. What is the ratio of the Enrollment rate (%) of Cambodia in 1999 to that in 2006?
Provide a short and direct response. 0.93. What is the ratio of the Enrollment rate (%) in Cyprus in 1999 to that in 2006?
Your answer should be compact. 0.98. What is the ratio of the Enrollment rate (%) of Burkina Faso in 1999 to that in 2008?
Offer a terse response. 0.64. What is the ratio of the Enrollment rate (%) of Cambodia in 1999 to that in 2008?
Provide a short and direct response. 0.92. What is the ratio of the Enrollment rate (%) of Cyprus in 1999 to that in 2008?
Provide a succinct answer. 0.99. What is the ratio of the Enrollment rate (%) of Burkina Faso in 1999 to that in 2010?
Ensure brevity in your answer.  0.66. What is the ratio of the Enrollment rate (%) of Cambodia in 1999 to that in 2010?
Offer a very short reply. 0.93. What is the ratio of the Enrollment rate (%) in Burkina Faso in 1999 to that in 2012?
Your answer should be compact. 0.61. What is the ratio of the Enrollment rate (%) in Cambodia in 1999 to that in 2012?
Offer a terse response. 0.92. What is the ratio of the Enrollment rate (%) of Burkina Faso in 2000 to that in 2003?
Offer a terse response. 0.96. What is the ratio of the Enrollment rate (%) of Cambodia in 2000 to that in 2003?
Provide a short and direct response. 0.98. What is the ratio of the Enrollment rate (%) in Burkina Faso in 2000 to that in 2006?
Keep it short and to the point. 0.79. What is the ratio of the Enrollment rate (%) in Cambodia in 2000 to that in 2006?
Make the answer very short. 0.98. What is the ratio of the Enrollment rate (%) of Cyprus in 2000 to that in 2006?
Your response must be concise. 0.98. What is the ratio of the Enrollment rate (%) in European Union in 2000 to that in 2008?
Your response must be concise. 1. What is the ratio of the Enrollment rate (%) in Burkina Faso in 2000 to that in 2008?
Your response must be concise. 0.66. What is the ratio of the Enrollment rate (%) in Cambodia in 2000 to that in 2008?
Provide a short and direct response. 0.98. What is the ratio of the Enrollment rate (%) in Cyprus in 2000 to that in 2008?
Ensure brevity in your answer.  0.98. What is the ratio of the Enrollment rate (%) of European Union in 2000 to that in 2010?
Ensure brevity in your answer.  1. What is the ratio of the Enrollment rate (%) in Burkina Faso in 2000 to that in 2010?
Give a very brief answer. 0.68. What is the ratio of the Enrollment rate (%) in Cambodia in 2000 to that in 2010?
Offer a very short reply. 0.99. What is the ratio of the Enrollment rate (%) in Cyprus in 2000 to that in 2010?
Ensure brevity in your answer.  0.99. What is the ratio of the Enrollment rate (%) in Burkina Faso in 2000 to that in 2012?
Offer a terse response. 0.63. What is the ratio of the Enrollment rate (%) of Cambodia in 2000 to that in 2012?
Your response must be concise. 0.98. What is the ratio of the Enrollment rate (%) in Cyprus in 2000 to that in 2012?
Provide a succinct answer. 1. What is the ratio of the Enrollment rate (%) in European Union in 2003 to that in 2006?
Your response must be concise. 1. What is the ratio of the Enrollment rate (%) of Burkina Faso in 2003 to that in 2006?
Provide a short and direct response. 0.82. What is the ratio of the Enrollment rate (%) of Cyprus in 2003 to that in 2006?
Ensure brevity in your answer.  0.99. What is the ratio of the Enrollment rate (%) in Burkina Faso in 2003 to that in 2008?
Provide a short and direct response. 0.68. What is the ratio of the Enrollment rate (%) of Cyprus in 2003 to that in 2008?
Keep it short and to the point. 0.99. What is the ratio of the Enrollment rate (%) of European Union in 2003 to that in 2010?
Keep it short and to the point. 1. What is the ratio of the Enrollment rate (%) of Burkina Faso in 2003 to that in 2010?
Offer a terse response. 0.71. What is the ratio of the Enrollment rate (%) of Cambodia in 2003 to that in 2010?
Provide a short and direct response. 1.01. What is the ratio of the Enrollment rate (%) in Burkina Faso in 2003 to that in 2012?
Ensure brevity in your answer.  0.65. What is the ratio of the Enrollment rate (%) of Cyprus in 2003 to that in 2012?
Provide a short and direct response. 1. What is the ratio of the Enrollment rate (%) in Burkina Faso in 2006 to that in 2008?
Your response must be concise. 0.83. What is the ratio of the Enrollment rate (%) of Cambodia in 2006 to that in 2008?
Provide a short and direct response. 0.99. What is the ratio of the Enrollment rate (%) in European Union in 2006 to that in 2010?
Keep it short and to the point. 1. What is the ratio of the Enrollment rate (%) in Burkina Faso in 2006 to that in 2010?
Your response must be concise. 0.87. What is the ratio of the Enrollment rate (%) of Cambodia in 2006 to that in 2010?
Keep it short and to the point. 1.01. What is the ratio of the Enrollment rate (%) in European Union in 2006 to that in 2012?
Provide a succinct answer. 1. What is the ratio of the Enrollment rate (%) of Burkina Faso in 2006 to that in 2012?
Provide a succinct answer. 0.8. What is the ratio of the Enrollment rate (%) in Cambodia in 2006 to that in 2012?
Offer a terse response. 0.99. What is the ratio of the Enrollment rate (%) of Cyprus in 2006 to that in 2012?
Provide a succinct answer. 1.02. What is the ratio of the Enrollment rate (%) of European Union in 2008 to that in 2010?
Provide a short and direct response. 1. What is the ratio of the Enrollment rate (%) of Burkina Faso in 2008 to that in 2010?
Make the answer very short. 1.04. What is the ratio of the Enrollment rate (%) of Cambodia in 2008 to that in 2010?
Give a very brief answer. 1.01. What is the ratio of the Enrollment rate (%) in European Union in 2008 to that in 2012?
Make the answer very short. 1. What is the ratio of the Enrollment rate (%) of Burkina Faso in 2008 to that in 2012?
Provide a short and direct response. 0.96. What is the ratio of the Enrollment rate (%) in Cyprus in 2008 to that in 2012?
Give a very brief answer. 1.01. What is the ratio of the Enrollment rate (%) of Burkina Faso in 2010 to that in 2012?
Your response must be concise. 0.92. What is the ratio of the Enrollment rate (%) in Cambodia in 2010 to that in 2012?
Your response must be concise. 0.99. What is the ratio of the Enrollment rate (%) of Cyprus in 2010 to that in 2012?
Your answer should be very brief. 1.01. What is the difference between the highest and the second highest Enrollment rate (%) in European Union?
Your response must be concise. 0.05. What is the difference between the highest and the second highest Enrollment rate (%) of Burkina Faso?
Your answer should be compact. 3.06. What is the difference between the highest and the second highest Enrollment rate (%) of Cambodia?
Your answer should be very brief. 0.07. What is the difference between the highest and the second highest Enrollment rate (%) in Cyprus?
Provide a succinct answer. 0.28. What is the difference between the highest and the lowest Enrollment rate (%) in European Union?
Offer a very short reply. 0.44. What is the difference between the highest and the lowest Enrollment rate (%) of Burkina Faso?
Offer a very short reply. 26.64. What is the difference between the highest and the lowest Enrollment rate (%) of Cambodia?
Provide a succinct answer. 7.77. What is the difference between the highest and the lowest Enrollment rate (%) of Cyprus?
Provide a short and direct response. 1.77. 